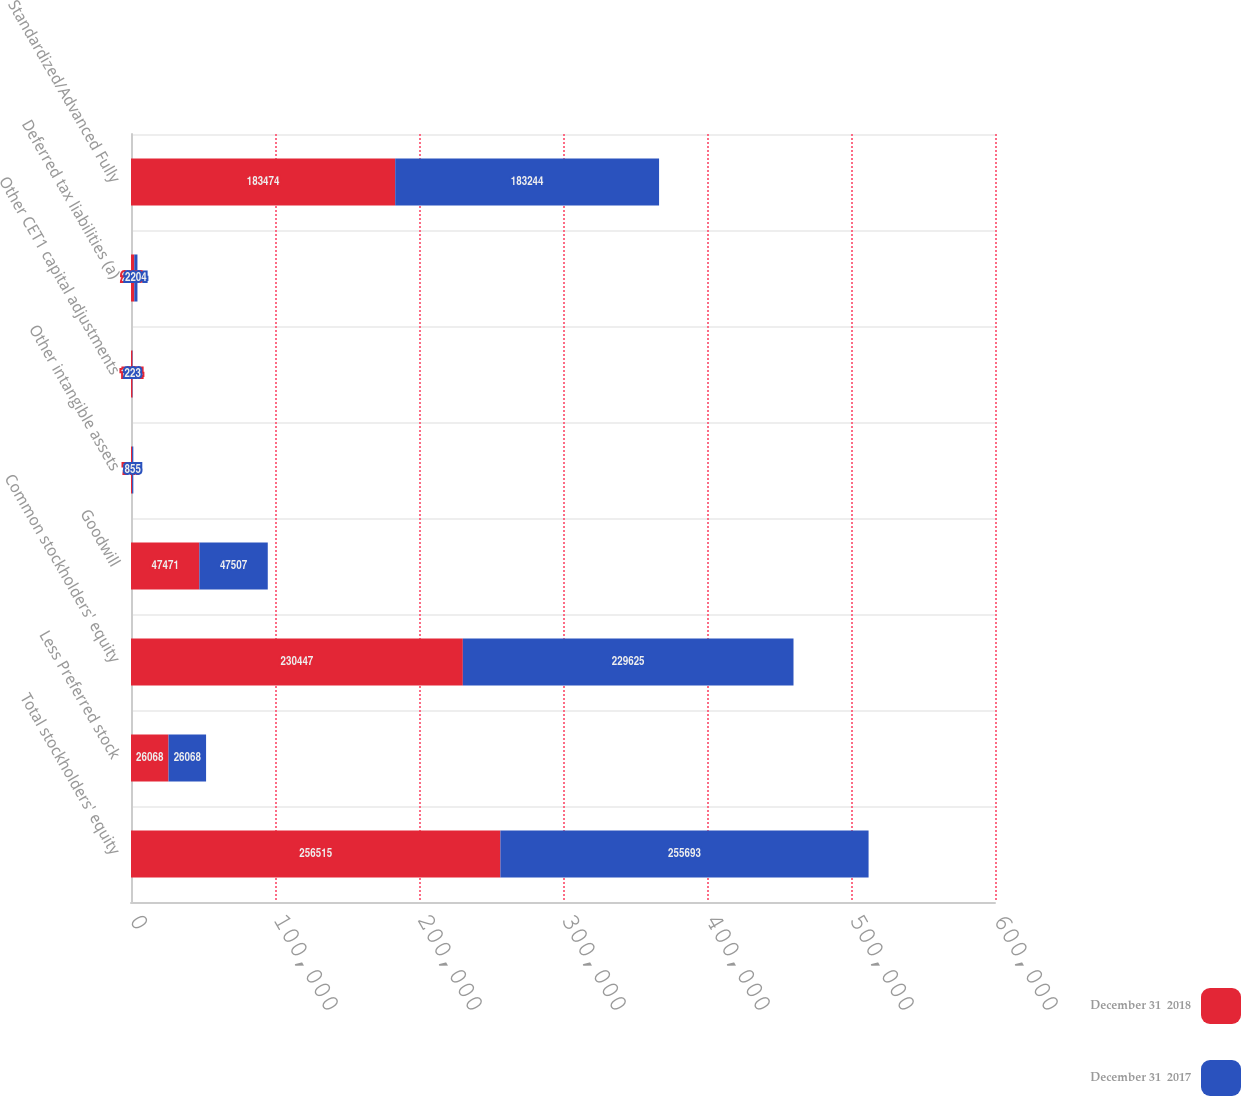Convert chart to OTSL. <chart><loc_0><loc_0><loc_500><loc_500><stacked_bar_chart><ecel><fcel>Total stockholders' equity<fcel>Less Preferred stock<fcel>Common stockholders' equity<fcel>Goodwill<fcel>Other intangible assets<fcel>Other CET1 capital adjustments<fcel>Deferred tax liabilities (a)<fcel>Standardized/Advanced Fully<nl><fcel>December 31  2018<fcel>256515<fcel>26068<fcel>230447<fcel>47471<fcel>748<fcel>1034<fcel>2280<fcel>183474<nl><fcel>December 31  2017<fcel>255693<fcel>26068<fcel>229625<fcel>47507<fcel>855<fcel>223<fcel>2204<fcel>183244<nl></chart> 